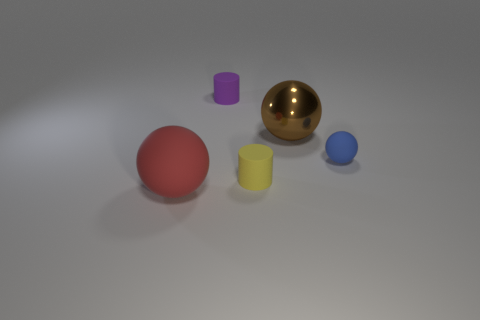If these objects were part of a game, what sort of game could it be? If these objects were part of a game, it could be a sorting or matching game. Players might be challenged to arrange the objects by color, size, or material properties. The variety in shapes and colors suggests they could also be used in an educational setting to teach these concepts to young children or as pieces in a board game tailored to sorting and strategy. 